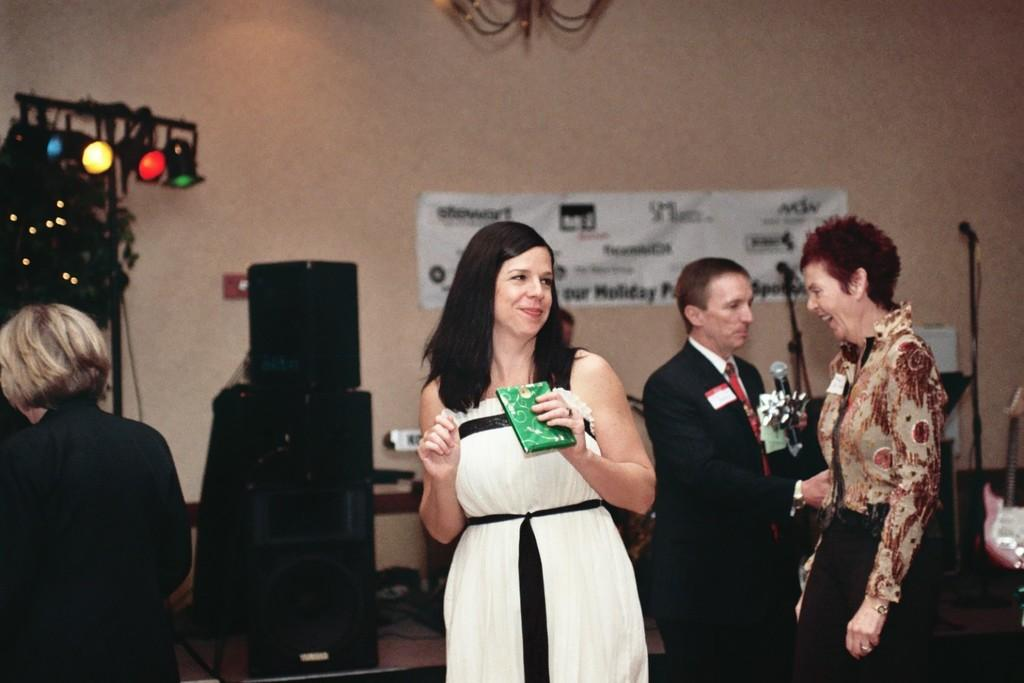What is the woman in the image wearing? The woman is wearing a white dress in the image. What is the woman holding in the image? The woman is holding a gift in the image. Can you describe the people behind the woman? There are two other persons behind the woman in the image. Is there anyone else in the image besides the woman and the two persons behind her? Yes, there is another woman standing in the left corner of the image. What type of oatmeal is being served at the event in the image? There is no event or oatmeal present in the image. What is the relationship between the woman and the person standing in the left corner of the image? The provided facts do not give any information about the relationship between the woman and the person standing in the left corner of the image. 